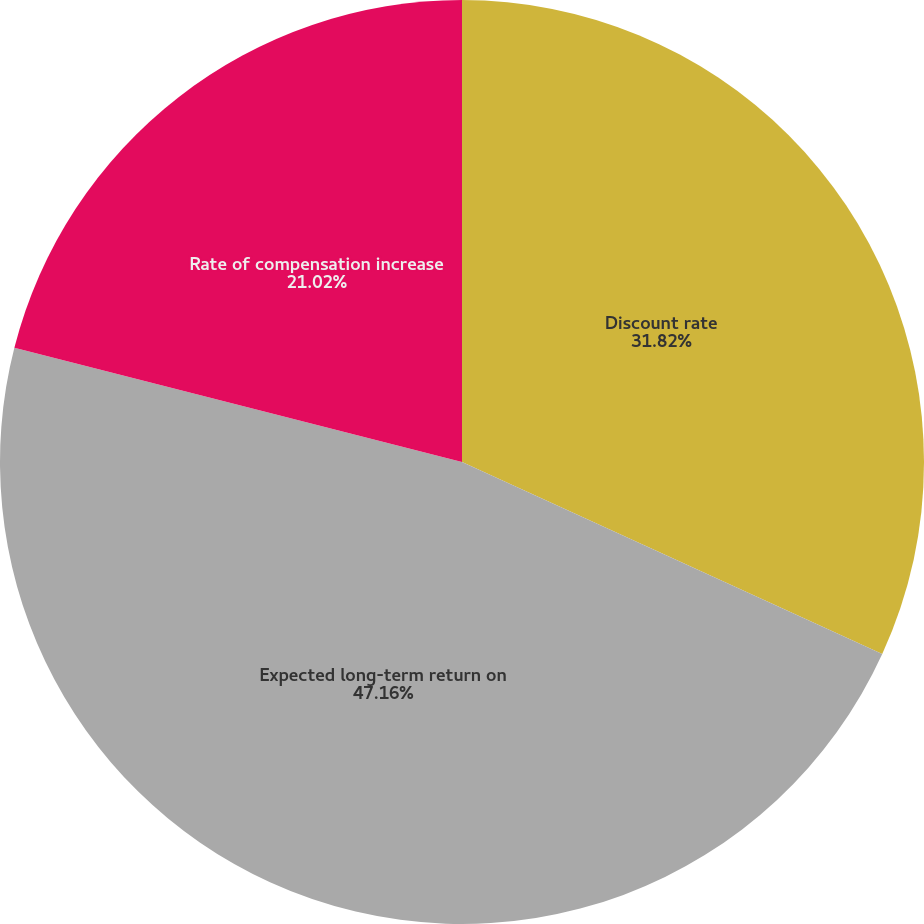Convert chart. <chart><loc_0><loc_0><loc_500><loc_500><pie_chart><fcel>Discount rate<fcel>Expected long-term return on<fcel>Rate of compensation increase<nl><fcel>31.82%<fcel>47.16%<fcel>21.02%<nl></chart> 